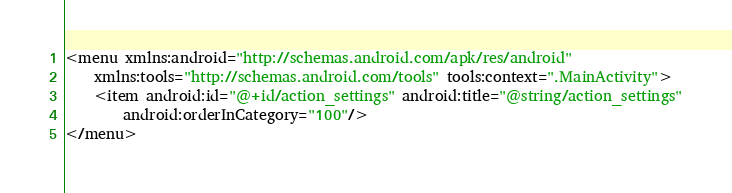<code> <loc_0><loc_0><loc_500><loc_500><_XML_><menu xmlns:android="http://schemas.android.com/apk/res/android"
    xmlns:tools="http://schemas.android.com/tools" tools:context=".MainActivity">
    <item android:id="@+id/action_settings" android:title="@string/action_settings"
        android:orderInCategory="100"/>
</menu></code> 